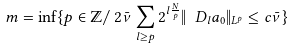Convert formula to latex. <formula><loc_0><loc_0><loc_500><loc_500>m = \inf \{ p \in \mathbb { Z } / \, 2 \bar { \nu } \sum _ { l \geq p } 2 ^ { l \frac { N } { p } } \| \ D _ { l } a _ { 0 } \| _ { L ^ { p } } \leq c \bar { \nu } \}</formula> 